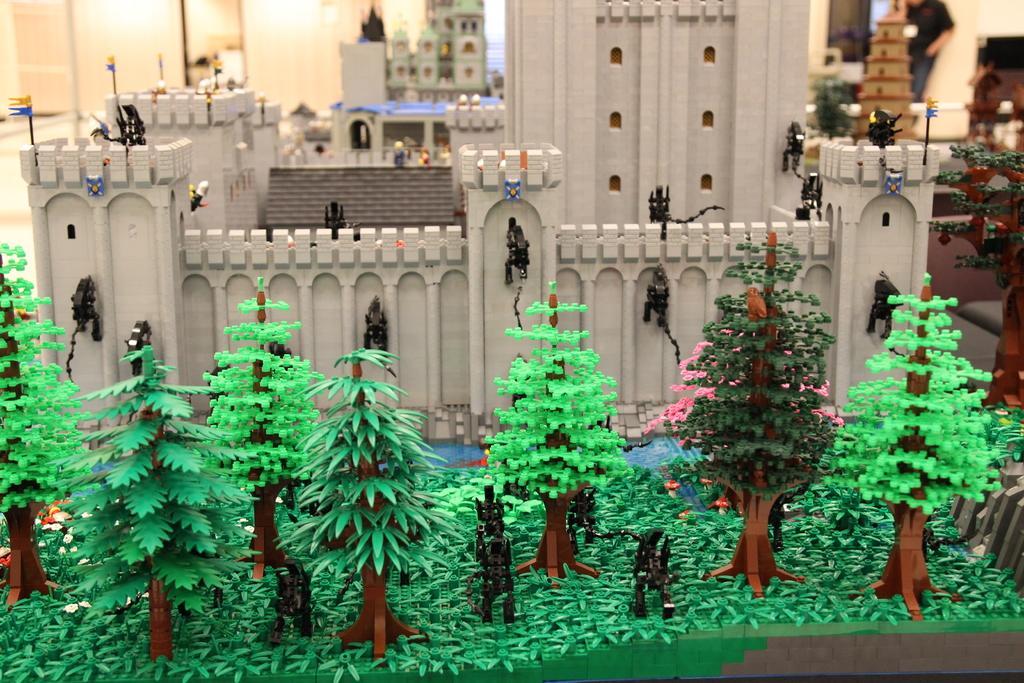In one or two sentences, can you explain what this image depicts? In this image we can see the depiction of buildings, fencing wall, trees, plants and also some other objects. In the background we can see the wall, lights and also a person. 